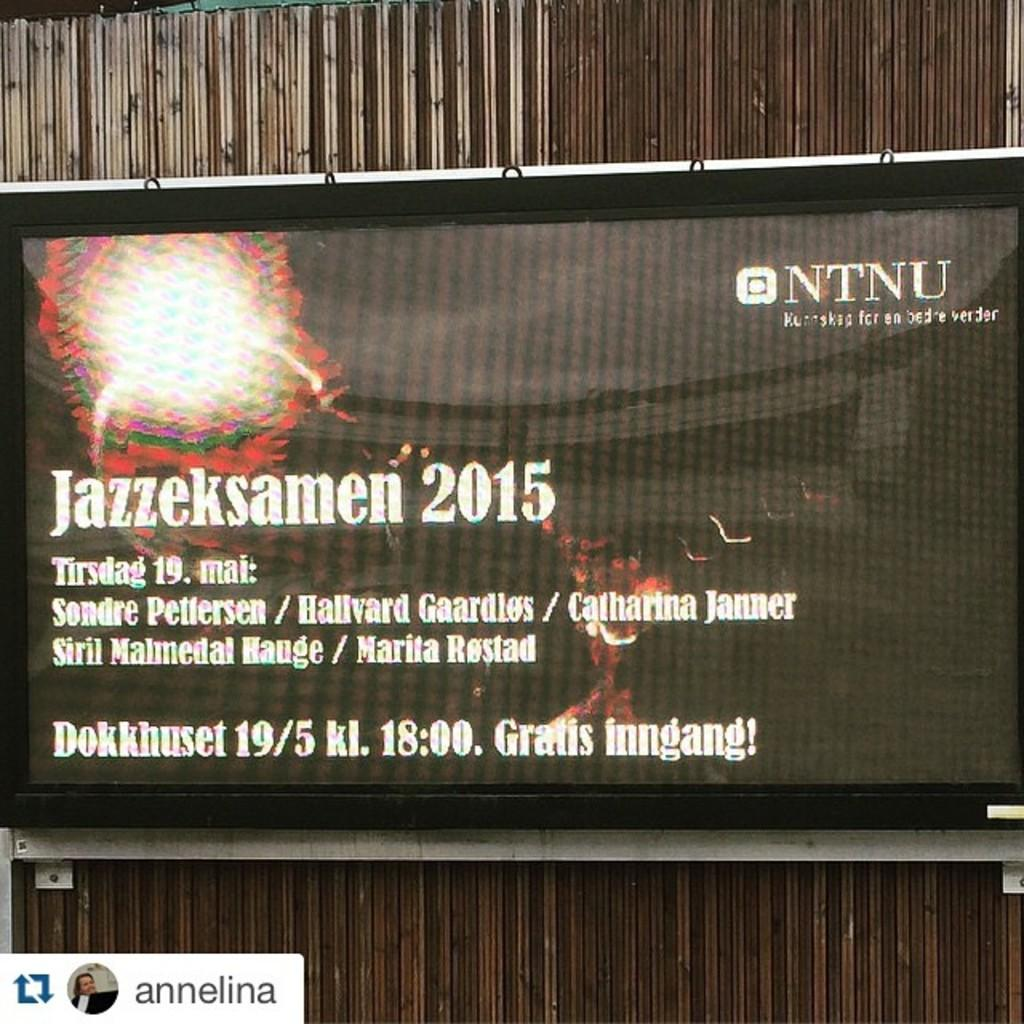Provide a one-sentence caption for the provided image. A screen displays information and details for Jazzeksamen 2015. 